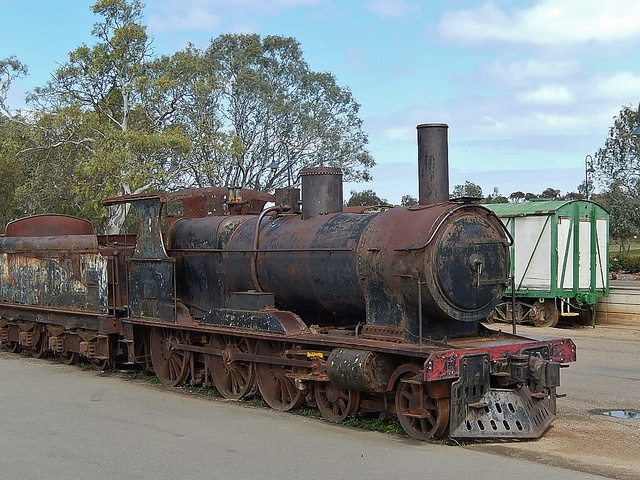Describe the objects in this image and their specific colors. I can see train in lightblue, black, gray, and maroon tones and train in lightblue, lightgray, black, teal, and darkgray tones in this image. 